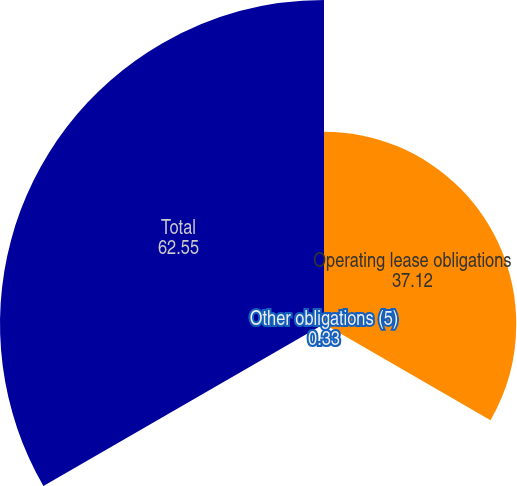Convert chart to OTSL. <chart><loc_0><loc_0><loc_500><loc_500><pie_chart><fcel>Operating lease obligations<fcel>Other obligations (5)<fcel>Total<nl><fcel>37.12%<fcel>0.33%<fcel>62.55%<nl></chart> 